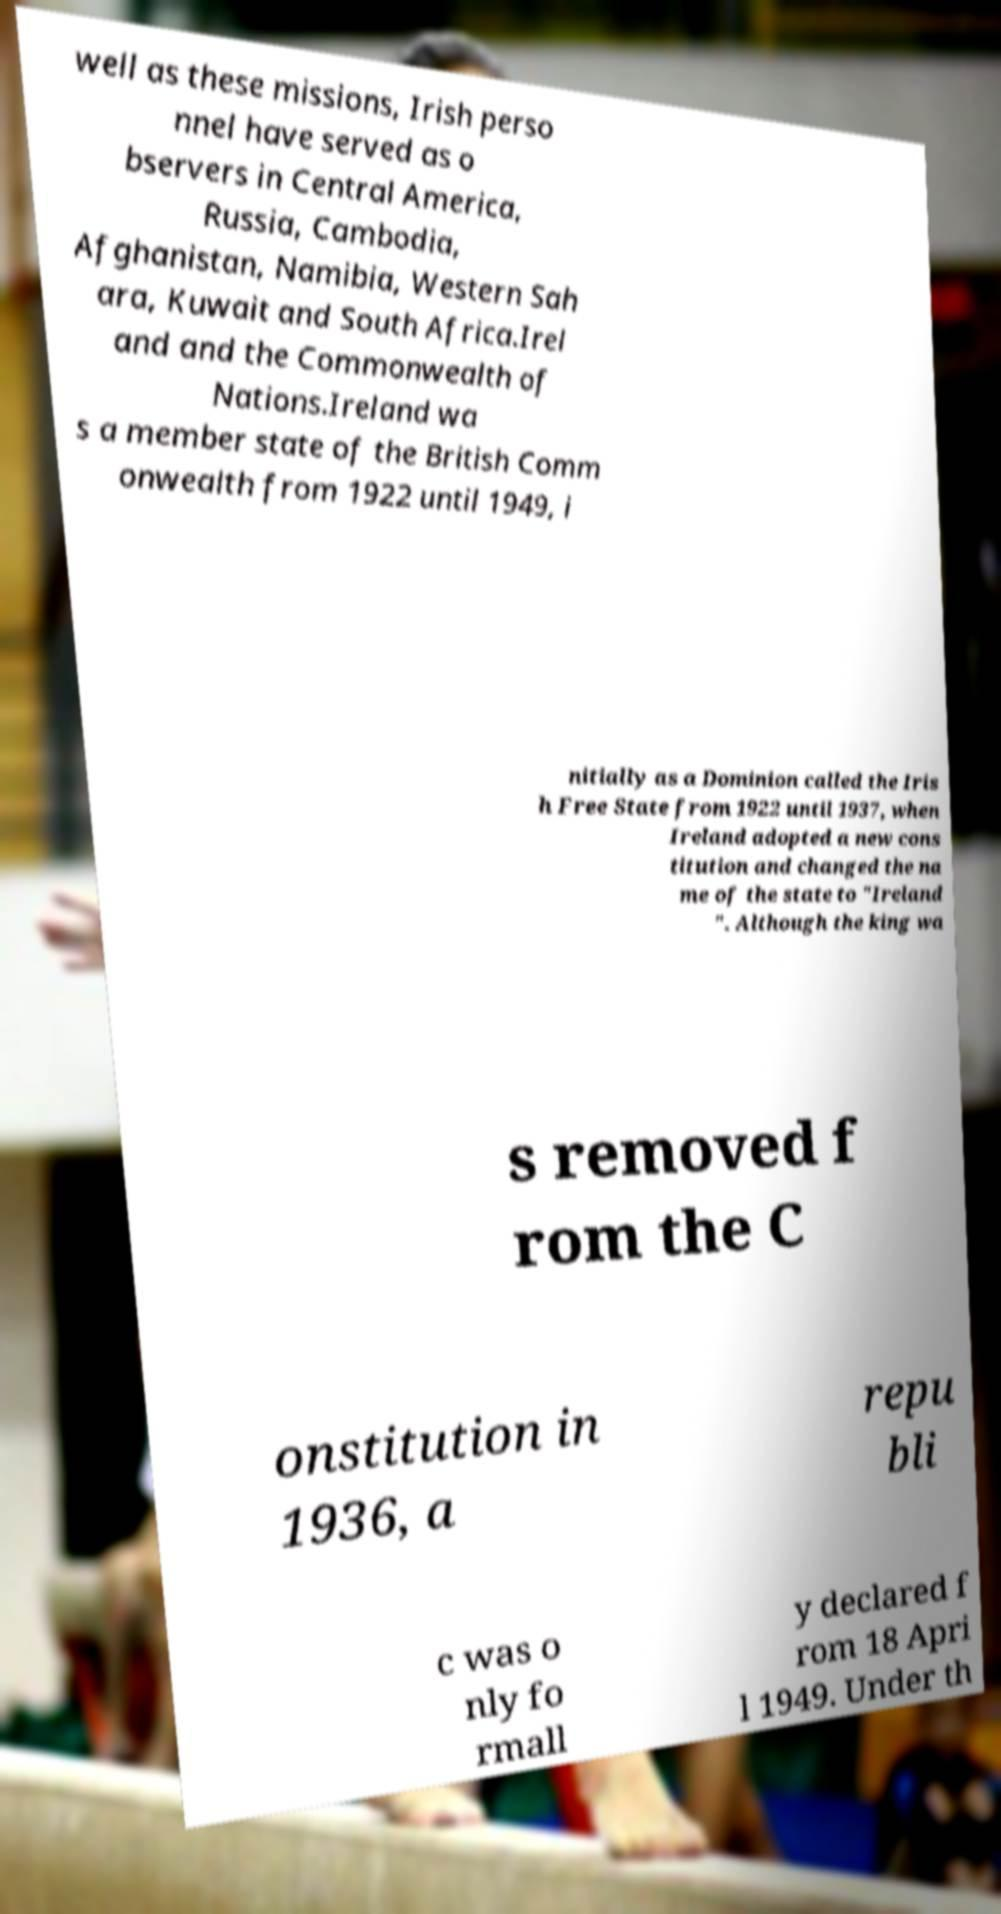Can you accurately transcribe the text from the provided image for me? well as these missions, Irish perso nnel have served as o bservers in Central America, Russia, Cambodia, Afghanistan, Namibia, Western Sah ara, Kuwait and South Africa.Irel and and the Commonwealth of Nations.Ireland wa s a member state of the British Comm onwealth from 1922 until 1949, i nitially as a Dominion called the Iris h Free State from 1922 until 1937, when Ireland adopted a new cons titution and changed the na me of the state to "Ireland ". Although the king wa s removed f rom the C onstitution in 1936, a repu bli c was o nly fo rmall y declared f rom 18 Apri l 1949. Under th 